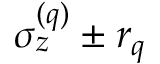<formula> <loc_0><loc_0><loc_500><loc_500>\sigma _ { z } ^ { ( q ) } \pm r _ { q }</formula> 